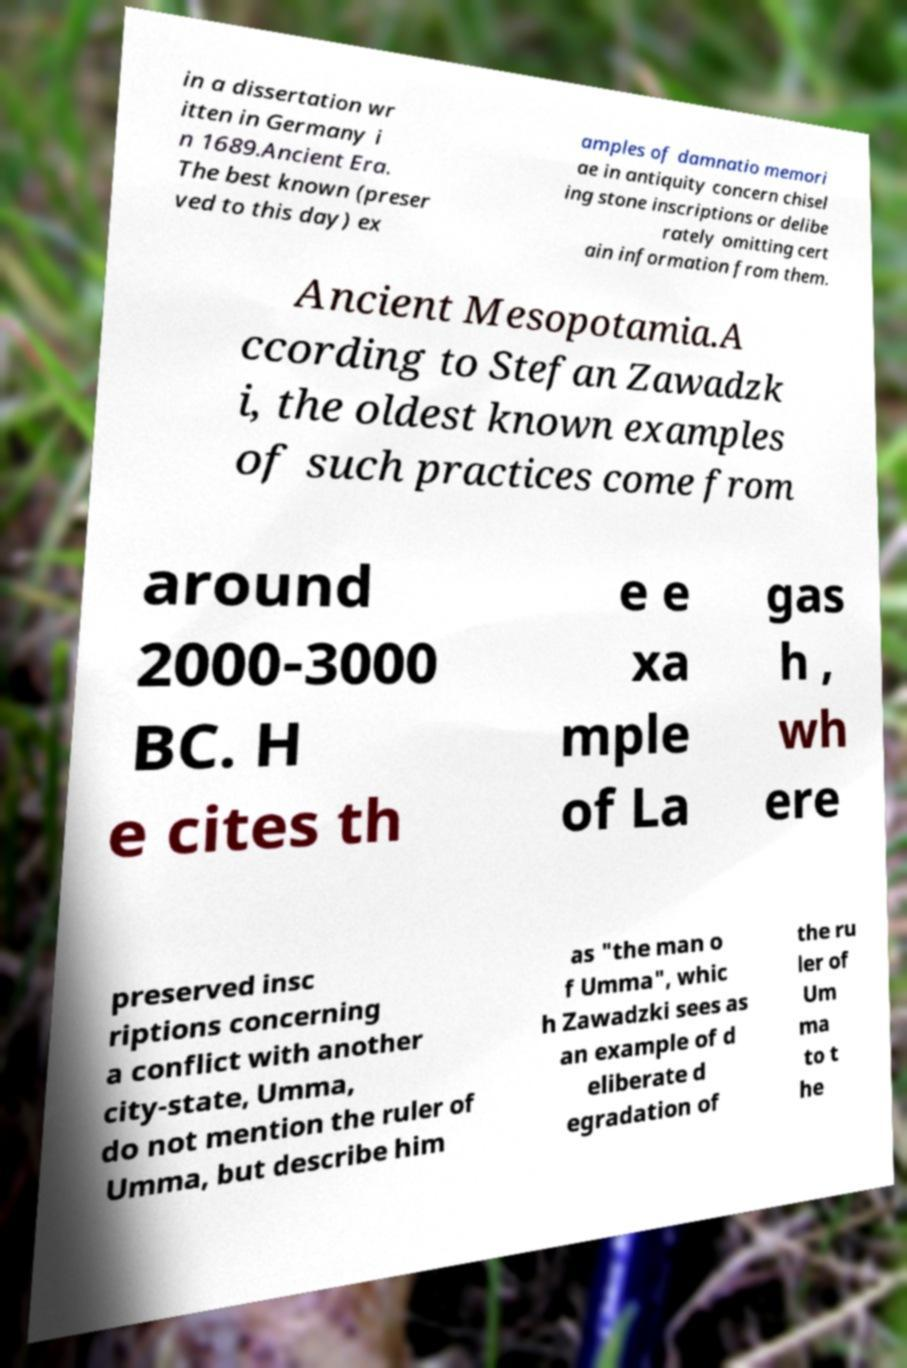Can you accurately transcribe the text from the provided image for me? in a dissertation wr itten in Germany i n 1689.Ancient Era. The best known (preser ved to this day) ex amples of damnatio memori ae in antiquity concern chisel ing stone inscriptions or delibe rately omitting cert ain information from them. Ancient Mesopotamia.A ccording to Stefan Zawadzk i, the oldest known examples of such practices come from around 2000-3000 BC. H e cites th e e xa mple of La gas h , wh ere preserved insc riptions concerning a conflict with another city-state, Umma, do not mention the ruler of Umma, but describe him as "the man o f Umma", whic h Zawadzki sees as an example of d eliberate d egradation of the ru ler of Um ma to t he 